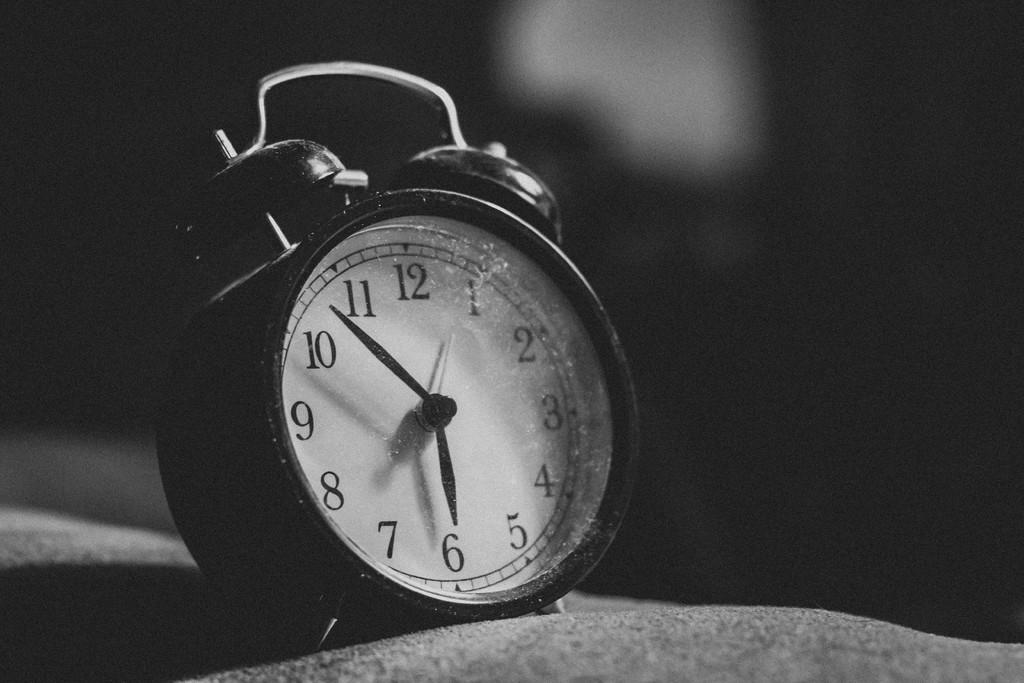<image>
Present a compact description of the photo's key features. A black and white picture of an old alarm clock that reads "6:50" 